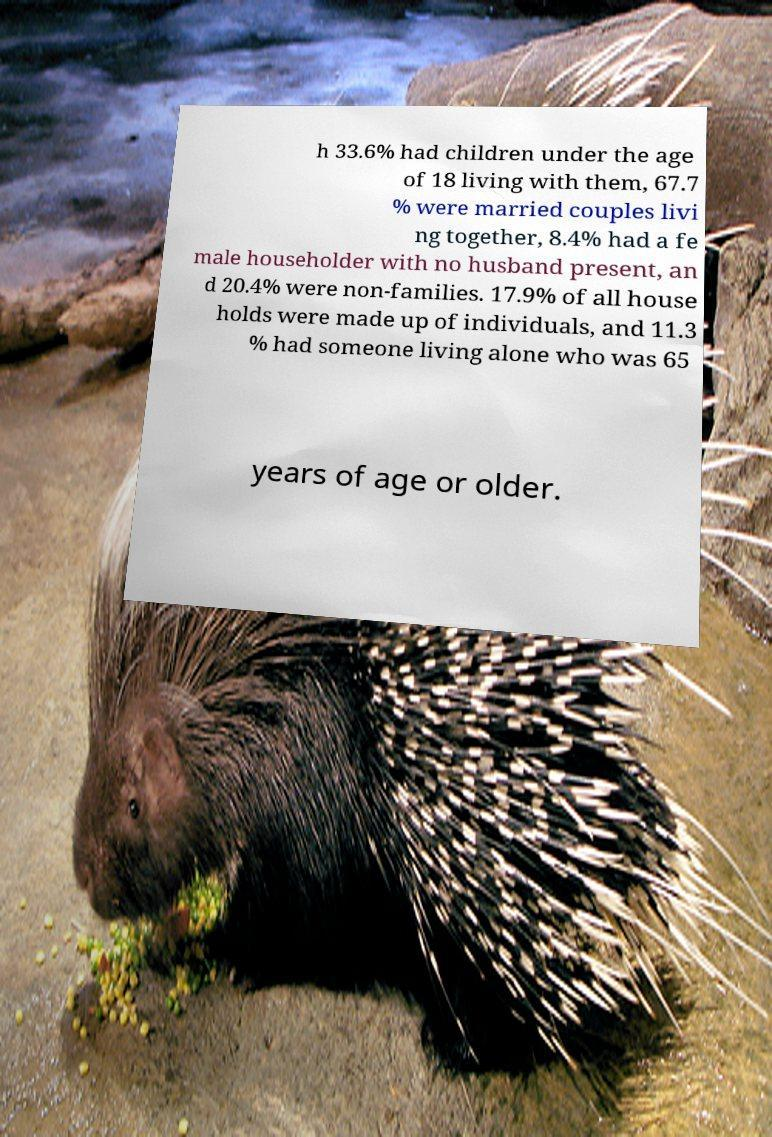There's text embedded in this image that I need extracted. Can you transcribe it verbatim? h 33.6% had children under the age of 18 living with them, 67.7 % were married couples livi ng together, 8.4% had a fe male householder with no husband present, an d 20.4% were non-families. 17.9% of all house holds were made up of individuals, and 11.3 % had someone living alone who was 65 years of age or older. 